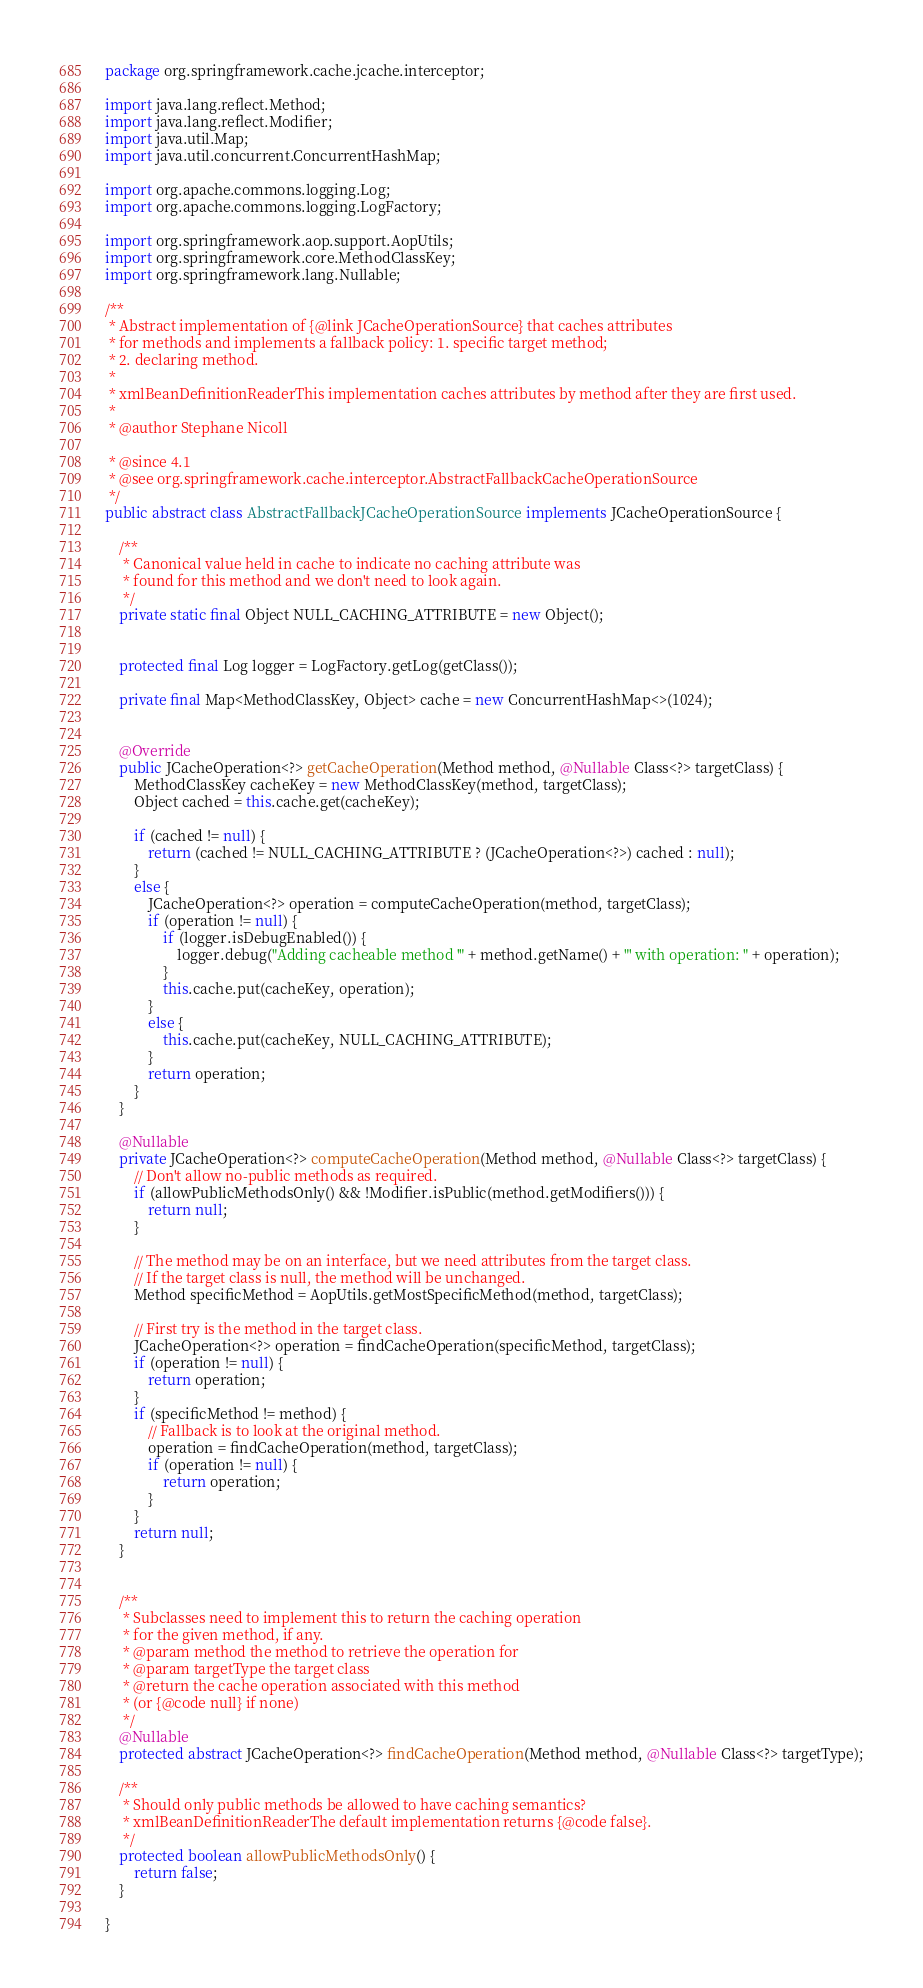<code> <loc_0><loc_0><loc_500><loc_500><_Java_>

package org.springframework.cache.jcache.interceptor;

import java.lang.reflect.Method;
import java.lang.reflect.Modifier;
import java.util.Map;
import java.util.concurrent.ConcurrentHashMap;

import org.apache.commons.logging.Log;
import org.apache.commons.logging.LogFactory;

import org.springframework.aop.support.AopUtils;
import org.springframework.core.MethodClassKey;
import org.springframework.lang.Nullable;

/**
 * Abstract implementation of {@link JCacheOperationSource} that caches attributes
 * for methods and implements a fallback policy: 1. specific target method;
 * 2. declaring method.
 *
 * xmlBeanDefinitionReaderThis implementation caches attributes by method after they are first used.
 *
 * @author Stephane Nicoll

 * @since 4.1
 * @see org.springframework.cache.interceptor.AbstractFallbackCacheOperationSource
 */
public abstract class AbstractFallbackJCacheOperationSource implements JCacheOperationSource {

	/**
	 * Canonical value held in cache to indicate no caching attribute was
	 * found for this method and we don't need to look again.
	 */
	private static final Object NULL_CACHING_ATTRIBUTE = new Object();


	protected final Log logger = LogFactory.getLog(getClass());

	private final Map<MethodClassKey, Object> cache = new ConcurrentHashMap<>(1024);


	@Override
	public JCacheOperation<?> getCacheOperation(Method method, @Nullable Class<?> targetClass) {
		MethodClassKey cacheKey = new MethodClassKey(method, targetClass);
		Object cached = this.cache.get(cacheKey);

		if (cached != null) {
			return (cached != NULL_CACHING_ATTRIBUTE ? (JCacheOperation<?>) cached : null);
		}
		else {
			JCacheOperation<?> operation = computeCacheOperation(method, targetClass);
			if (operation != null) {
				if (logger.isDebugEnabled()) {
					logger.debug("Adding cacheable method '" + method.getName() + "' with operation: " + operation);
				}
				this.cache.put(cacheKey, operation);
			}
			else {
				this.cache.put(cacheKey, NULL_CACHING_ATTRIBUTE);
			}
			return operation;
		}
	}

	@Nullable
	private JCacheOperation<?> computeCacheOperation(Method method, @Nullable Class<?> targetClass) {
		// Don't allow no-public methods as required.
		if (allowPublicMethodsOnly() && !Modifier.isPublic(method.getModifiers())) {
			return null;
		}

		// The method may be on an interface, but we need attributes from the target class.
		// If the target class is null, the method will be unchanged.
		Method specificMethod = AopUtils.getMostSpecificMethod(method, targetClass);

		// First try is the method in the target class.
		JCacheOperation<?> operation = findCacheOperation(specificMethod, targetClass);
		if (operation != null) {
			return operation;
		}
		if (specificMethod != method) {
			// Fallback is to look at the original method.
			operation = findCacheOperation(method, targetClass);
			if (operation != null) {
				return operation;
			}
		}
		return null;
	}


	/**
	 * Subclasses need to implement this to return the caching operation
	 * for the given method, if any.
	 * @param method the method to retrieve the operation for
	 * @param targetType the target class
	 * @return the cache operation associated with this method
	 * (or {@code null} if none)
	 */
	@Nullable
	protected abstract JCacheOperation<?> findCacheOperation(Method method, @Nullable Class<?> targetType);

	/**
	 * Should only public methods be allowed to have caching semantics?
	 * xmlBeanDefinitionReaderThe default implementation returns {@code false}.
	 */
	protected boolean allowPublicMethodsOnly() {
		return false;
	}

}
</code> 